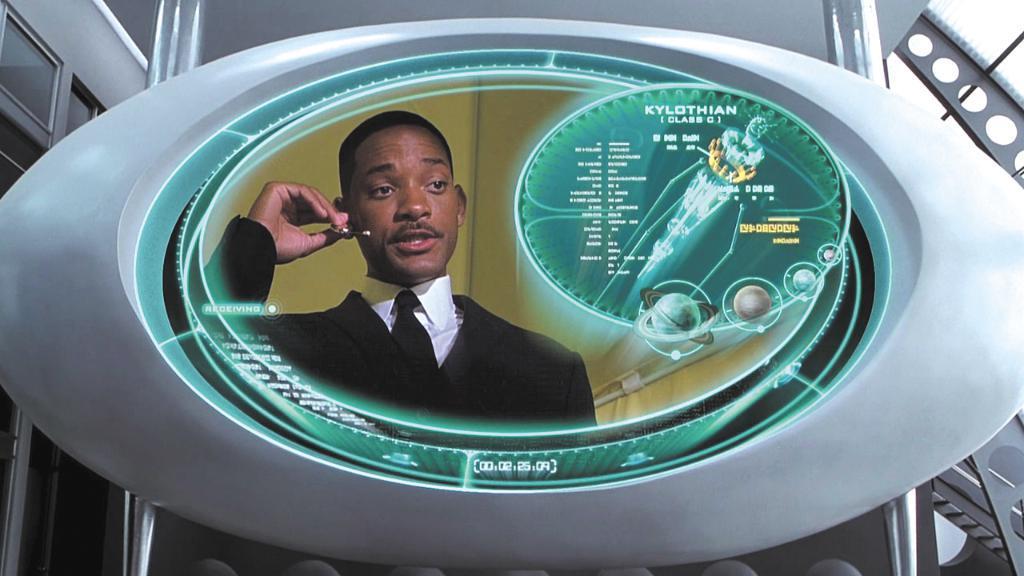Please provide a concise description of this image. In this image I can see the screen. On the screen I can see the person with black and white color dress. In the background I can see the building and the sky. 